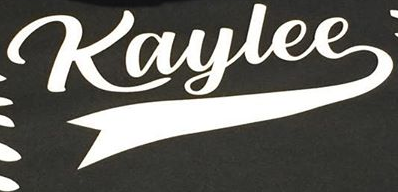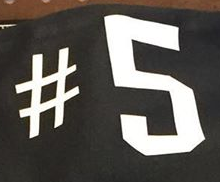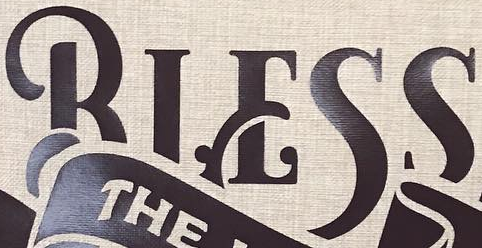Transcribe the words shown in these images in order, separated by a semicolon. Kaylee; #5; BIESS 